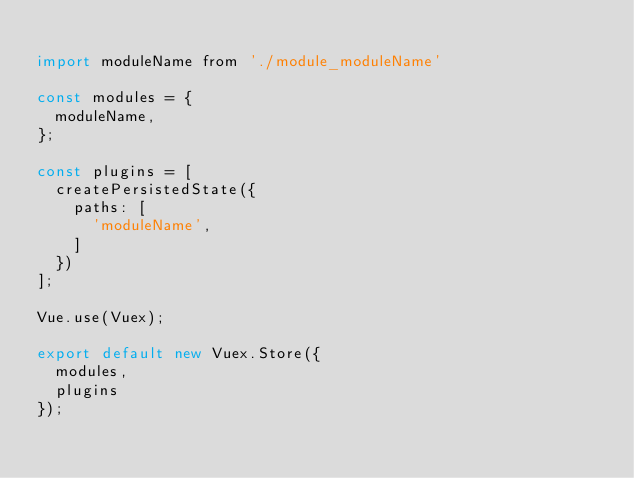Convert code to text. <code><loc_0><loc_0><loc_500><loc_500><_JavaScript_>
import moduleName from './module_moduleName'

const modules = {
  moduleName,
};

const plugins = [
  createPersistedState({
    paths: [
      'moduleName',
    ]
  })
];

Vue.use(Vuex);

export default new Vuex.Store({
  modules,
  plugins
});
</code> 